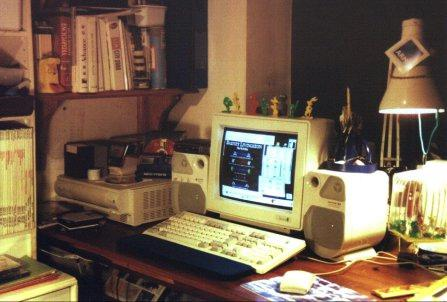Question: what is the computer mouse on?
Choices:
A. The desk.
B. A pad.
C. A pizza box.
D. His lap.
Answer with the letter. Answer: B Question: where is the computer?
Choices:
A. In the office.
B. On the desk.
C. Upstairs.
D. In the kitchen.
Answer with the letter. Answer: B Question: why are the speakers needed?
Choices:
A. To hear the music.
B. So the stadium can hear the singer preform.
C. Audio.
D. So I can hear the movie.
Answer with the letter. Answer: C 